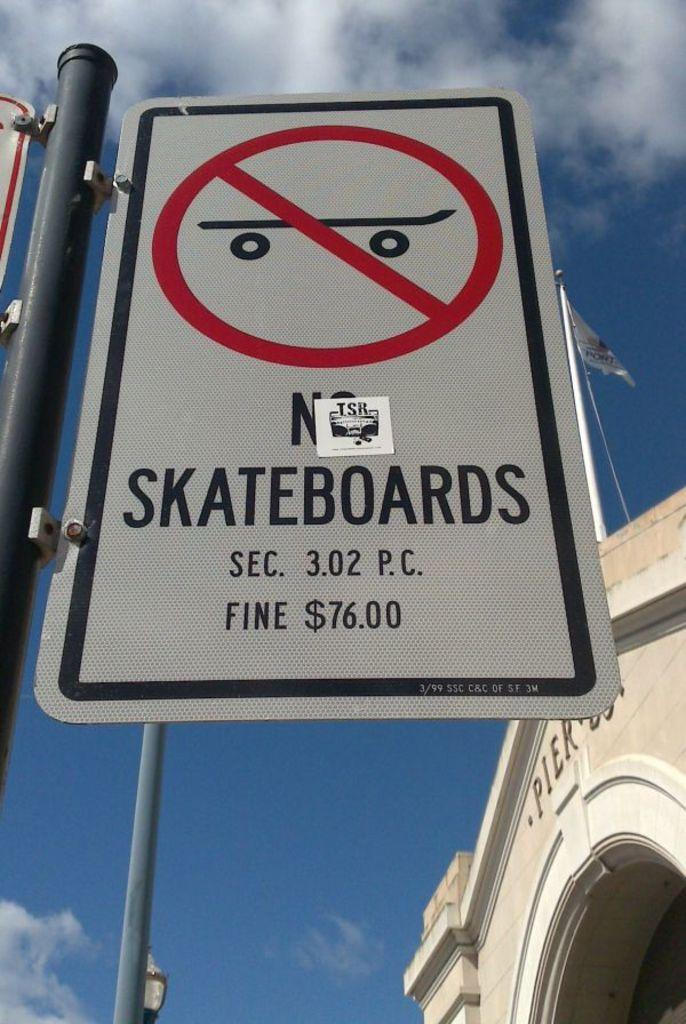Provide a one-sentence caption for the provided image. You are not allowed to skateboard on this sidewalk. 